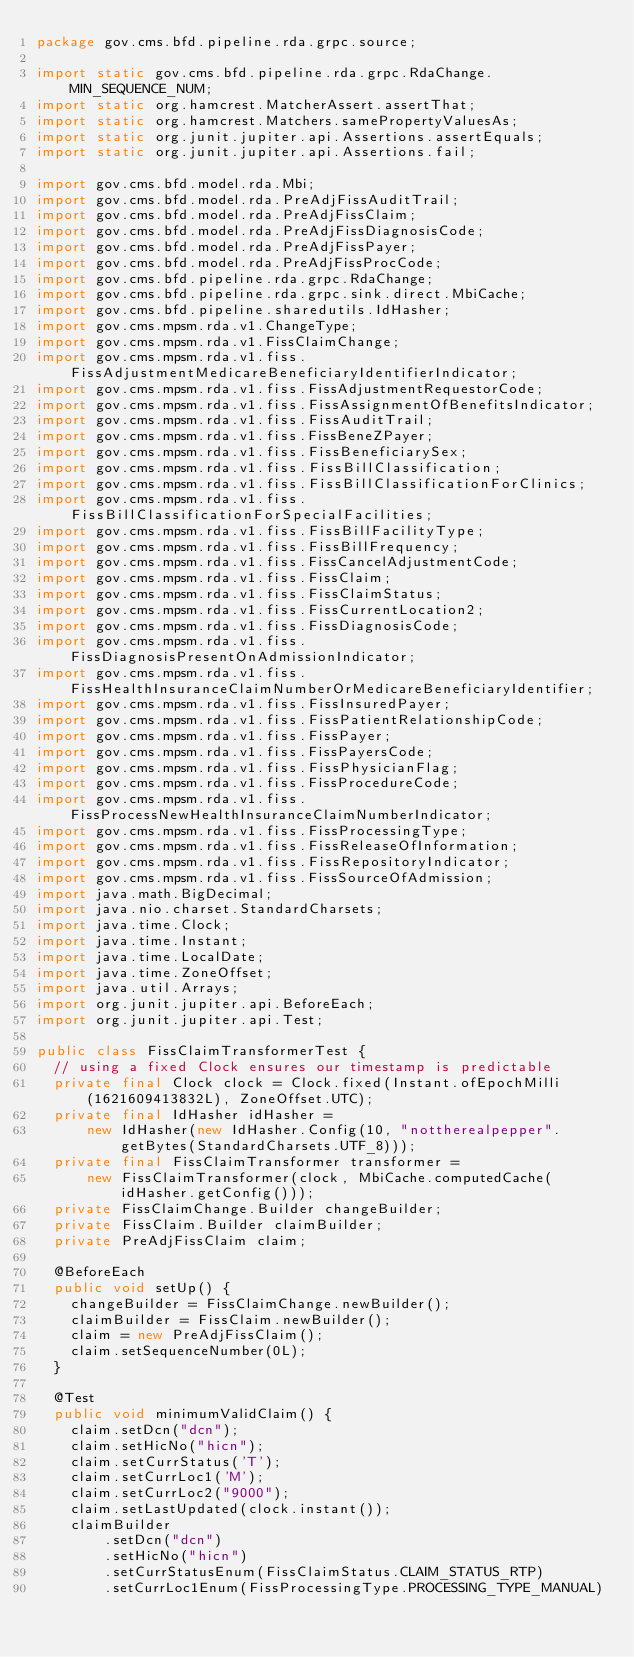Convert code to text. <code><loc_0><loc_0><loc_500><loc_500><_Java_>package gov.cms.bfd.pipeline.rda.grpc.source;

import static gov.cms.bfd.pipeline.rda.grpc.RdaChange.MIN_SEQUENCE_NUM;
import static org.hamcrest.MatcherAssert.assertThat;
import static org.hamcrest.Matchers.samePropertyValuesAs;
import static org.junit.jupiter.api.Assertions.assertEquals;
import static org.junit.jupiter.api.Assertions.fail;

import gov.cms.bfd.model.rda.Mbi;
import gov.cms.bfd.model.rda.PreAdjFissAuditTrail;
import gov.cms.bfd.model.rda.PreAdjFissClaim;
import gov.cms.bfd.model.rda.PreAdjFissDiagnosisCode;
import gov.cms.bfd.model.rda.PreAdjFissPayer;
import gov.cms.bfd.model.rda.PreAdjFissProcCode;
import gov.cms.bfd.pipeline.rda.grpc.RdaChange;
import gov.cms.bfd.pipeline.rda.grpc.sink.direct.MbiCache;
import gov.cms.bfd.pipeline.sharedutils.IdHasher;
import gov.cms.mpsm.rda.v1.ChangeType;
import gov.cms.mpsm.rda.v1.FissClaimChange;
import gov.cms.mpsm.rda.v1.fiss.FissAdjustmentMedicareBeneficiaryIdentifierIndicator;
import gov.cms.mpsm.rda.v1.fiss.FissAdjustmentRequestorCode;
import gov.cms.mpsm.rda.v1.fiss.FissAssignmentOfBenefitsIndicator;
import gov.cms.mpsm.rda.v1.fiss.FissAuditTrail;
import gov.cms.mpsm.rda.v1.fiss.FissBeneZPayer;
import gov.cms.mpsm.rda.v1.fiss.FissBeneficiarySex;
import gov.cms.mpsm.rda.v1.fiss.FissBillClassification;
import gov.cms.mpsm.rda.v1.fiss.FissBillClassificationForClinics;
import gov.cms.mpsm.rda.v1.fiss.FissBillClassificationForSpecialFacilities;
import gov.cms.mpsm.rda.v1.fiss.FissBillFacilityType;
import gov.cms.mpsm.rda.v1.fiss.FissBillFrequency;
import gov.cms.mpsm.rda.v1.fiss.FissCancelAdjustmentCode;
import gov.cms.mpsm.rda.v1.fiss.FissClaim;
import gov.cms.mpsm.rda.v1.fiss.FissClaimStatus;
import gov.cms.mpsm.rda.v1.fiss.FissCurrentLocation2;
import gov.cms.mpsm.rda.v1.fiss.FissDiagnosisCode;
import gov.cms.mpsm.rda.v1.fiss.FissDiagnosisPresentOnAdmissionIndicator;
import gov.cms.mpsm.rda.v1.fiss.FissHealthInsuranceClaimNumberOrMedicareBeneficiaryIdentifier;
import gov.cms.mpsm.rda.v1.fiss.FissInsuredPayer;
import gov.cms.mpsm.rda.v1.fiss.FissPatientRelationshipCode;
import gov.cms.mpsm.rda.v1.fiss.FissPayer;
import gov.cms.mpsm.rda.v1.fiss.FissPayersCode;
import gov.cms.mpsm.rda.v1.fiss.FissPhysicianFlag;
import gov.cms.mpsm.rda.v1.fiss.FissProcedureCode;
import gov.cms.mpsm.rda.v1.fiss.FissProcessNewHealthInsuranceClaimNumberIndicator;
import gov.cms.mpsm.rda.v1.fiss.FissProcessingType;
import gov.cms.mpsm.rda.v1.fiss.FissReleaseOfInformation;
import gov.cms.mpsm.rda.v1.fiss.FissRepositoryIndicator;
import gov.cms.mpsm.rda.v1.fiss.FissSourceOfAdmission;
import java.math.BigDecimal;
import java.nio.charset.StandardCharsets;
import java.time.Clock;
import java.time.Instant;
import java.time.LocalDate;
import java.time.ZoneOffset;
import java.util.Arrays;
import org.junit.jupiter.api.BeforeEach;
import org.junit.jupiter.api.Test;

public class FissClaimTransformerTest {
  // using a fixed Clock ensures our timestamp is predictable
  private final Clock clock = Clock.fixed(Instant.ofEpochMilli(1621609413832L), ZoneOffset.UTC);
  private final IdHasher idHasher =
      new IdHasher(new IdHasher.Config(10, "nottherealpepper".getBytes(StandardCharsets.UTF_8)));
  private final FissClaimTransformer transformer =
      new FissClaimTransformer(clock, MbiCache.computedCache(idHasher.getConfig()));
  private FissClaimChange.Builder changeBuilder;
  private FissClaim.Builder claimBuilder;
  private PreAdjFissClaim claim;

  @BeforeEach
  public void setUp() {
    changeBuilder = FissClaimChange.newBuilder();
    claimBuilder = FissClaim.newBuilder();
    claim = new PreAdjFissClaim();
    claim.setSequenceNumber(0L);
  }

  @Test
  public void minimumValidClaim() {
    claim.setDcn("dcn");
    claim.setHicNo("hicn");
    claim.setCurrStatus('T');
    claim.setCurrLoc1('M');
    claim.setCurrLoc2("9000");
    claim.setLastUpdated(clock.instant());
    claimBuilder
        .setDcn("dcn")
        .setHicNo("hicn")
        .setCurrStatusEnum(FissClaimStatus.CLAIM_STATUS_RTP)
        .setCurrLoc1Enum(FissProcessingType.PROCESSING_TYPE_MANUAL)</code> 